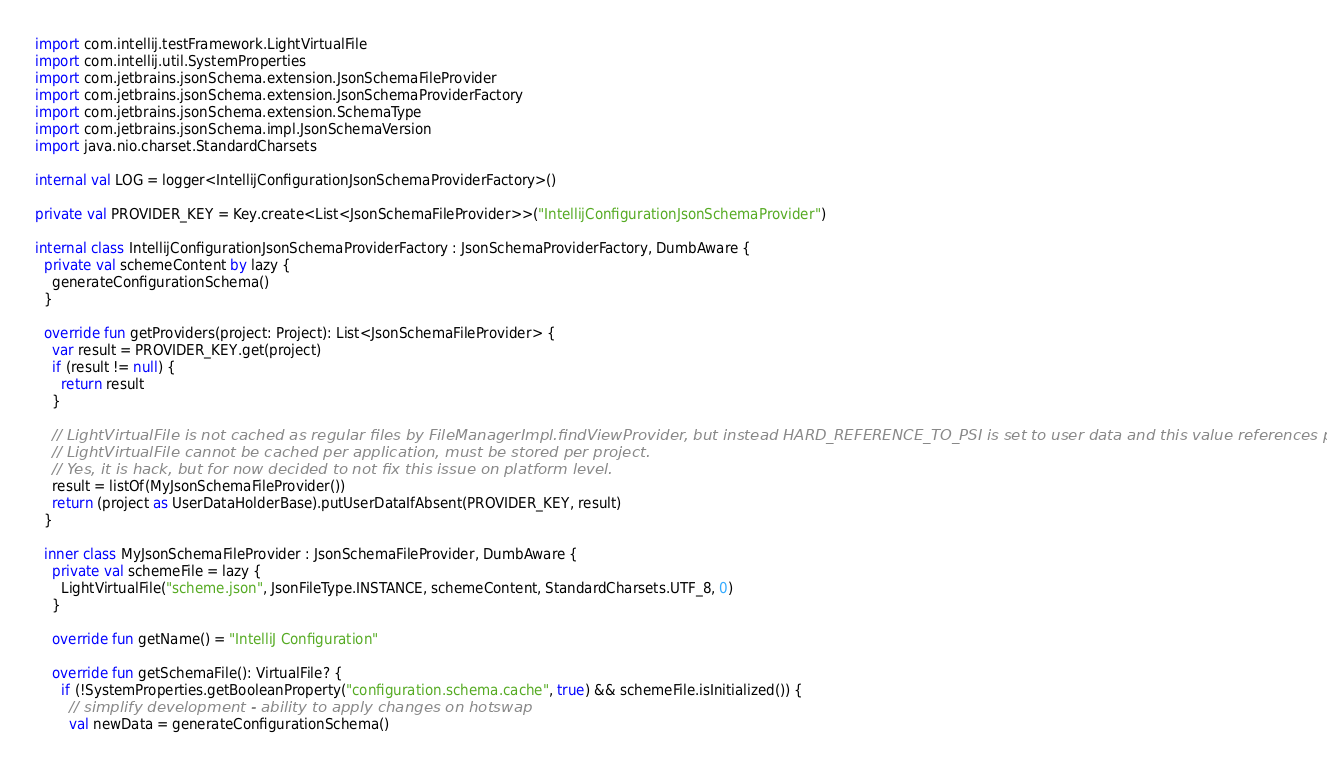Convert code to text. <code><loc_0><loc_0><loc_500><loc_500><_Kotlin_>import com.intellij.testFramework.LightVirtualFile
import com.intellij.util.SystemProperties
import com.jetbrains.jsonSchema.extension.JsonSchemaFileProvider
import com.jetbrains.jsonSchema.extension.JsonSchemaProviderFactory
import com.jetbrains.jsonSchema.extension.SchemaType
import com.jetbrains.jsonSchema.impl.JsonSchemaVersion
import java.nio.charset.StandardCharsets

internal val LOG = logger<IntellijConfigurationJsonSchemaProviderFactory>()

private val PROVIDER_KEY = Key.create<List<JsonSchemaFileProvider>>("IntellijConfigurationJsonSchemaProvider")

internal class IntellijConfigurationJsonSchemaProviderFactory : JsonSchemaProviderFactory, DumbAware {
  private val schemeContent by lazy {
    generateConfigurationSchema()
  }

  override fun getProviders(project: Project): List<JsonSchemaFileProvider> {
    var result = PROVIDER_KEY.get(project)
    if (result != null) {
      return result
    }

    // LightVirtualFile is not cached as regular files by FileManagerImpl.findViewProvider, but instead HARD_REFERENCE_TO_PSI is set to user data and this value references project and so,
    // LightVirtualFile cannot be cached per application, must be stored per project.
    // Yes, it is hack, but for now decided to not fix this issue on platform level.
    result = listOf(MyJsonSchemaFileProvider())
    return (project as UserDataHolderBase).putUserDataIfAbsent(PROVIDER_KEY, result)
  }

  inner class MyJsonSchemaFileProvider : JsonSchemaFileProvider, DumbAware {
    private val schemeFile = lazy {
      LightVirtualFile("scheme.json", JsonFileType.INSTANCE, schemeContent, StandardCharsets.UTF_8, 0)
    }

    override fun getName() = "IntelliJ Configuration"

    override fun getSchemaFile(): VirtualFile? {
      if (!SystemProperties.getBooleanProperty("configuration.schema.cache", true) && schemeFile.isInitialized()) {
        // simplify development - ability to apply changes on hotswap
        val newData = generateConfigurationSchema()</code> 